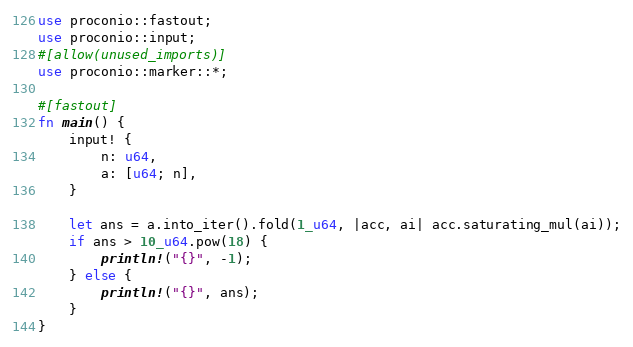<code> <loc_0><loc_0><loc_500><loc_500><_Rust_>use proconio::fastout;
use proconio::input;
#[allow(unused_imports)]
use proconio::marker::*;

#[fastout]
fn main() {
    input! {
        n: u64,
        a: [u64; n],
    }

    let ans = a.into_iter().fold(1_u64, |acc, ai| acc.saturating_mul(ai));
    if ans > 10_u64.pow(18) {
        println!("{}", -1);
    } else {
        println!("{}", ans);
    }
}
</code> 